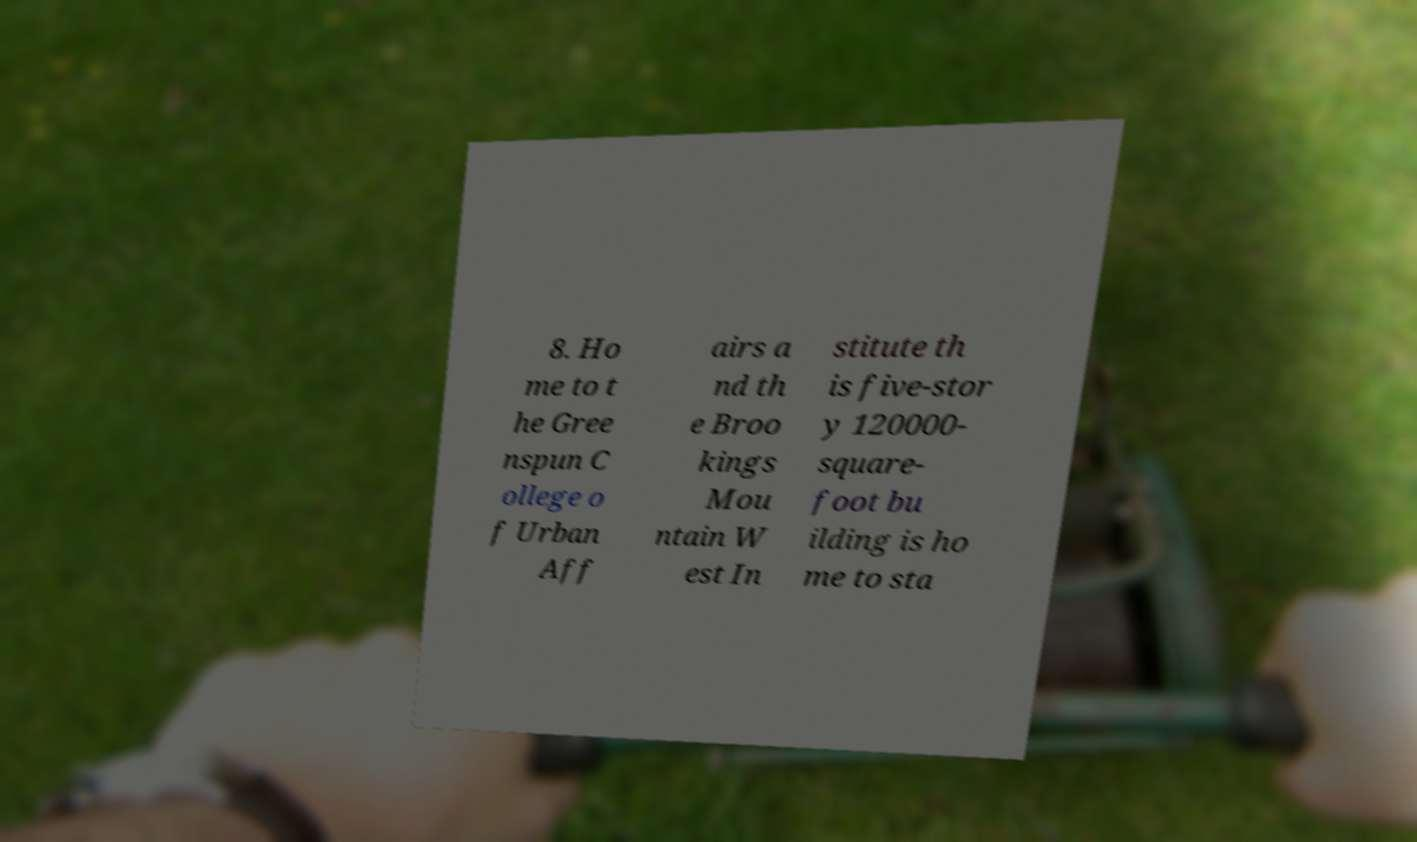There's text embedded in this image that I need extracted. Can you transcribe it verbatim? 8. Ho me to t he Gree nspun C ollege o f Urban Aff airs a nd th e Broo kings Mou ntain W est In stitute th is five-stor y 120000- square- foot bu ilding is ho me to sta 